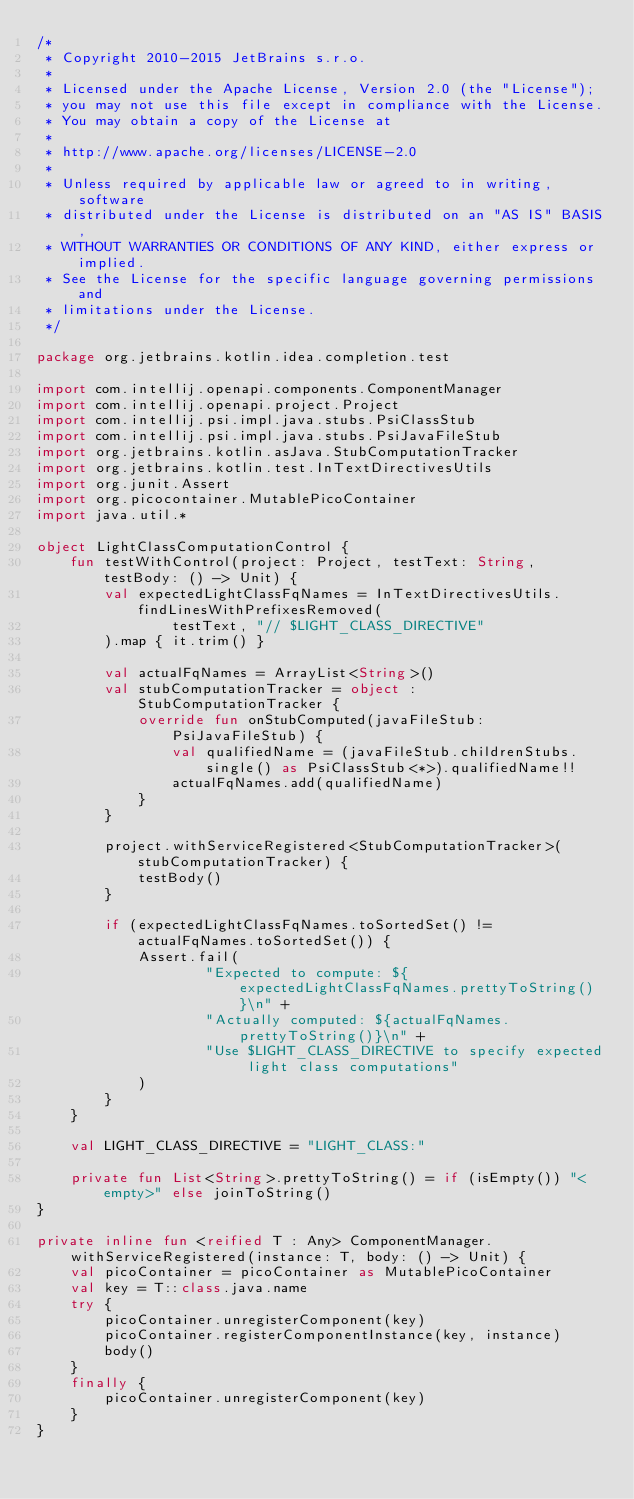<code> <loc_0><loc_0><loc_500><loc_500><_Kotlin_>/*
 * Copyright 2010-2015 JetBrains s.r.o.
 *
 * Licensed under the Apache License, Version 2.0 (the "License");
 * you may not use this file except in compliance with the License.
 * You may obtain a copy of the License at
 *
 * http://www.apache.org/licenses/LICENSE-2.0
 *
 * Unless required by applicable law or agreed to in writing, software
 * distributed under the License is distributed on an "AS IS" BASIS,
 * WITHOUT WARRANTIES OR CONDITIONS OF ANY KIND, either express or implied.
 * See the License for the specific language governing permissions and
 * limitations under the License.
 */

package org.jetbrains.kotlin.idea.completion.test

import com.intellij.openapi.components.ComponentManager
import com.intellij.openapi.project.Project
import com.intellij.psi.impl.java.stubs.PsiClassStub
import com.intellij.psi.impl.java.stubs.PsiJavaFileStub
import org.jetbrains.kotlin.asJava.StubComputationTracker
import org.jetbrains.kotlin.test.InTextDirectivesUtils
import org.junit.Assert
import org.picocontainer.MutablePicoContainer
import java.util.*

object LightClassComputationControl {
    fun testWithControl(project: Project, testText: String, testBody: () -> Unit) {
        val expectedLightClassFqNames = InTextDirectivesUtils.findLinesWithPrefixesRemoved(
                testText, "// $LIGHT_CLASS_DIRECTIVE"
        ).map { it.trim() }

        val actualFqNames = ArrayList<String>()
        val stubComputationTracker = object : StubComputationTracker {
            override fun onStubComputed(javaFileStub: PsiJavaFileStub) {
                val qualifiedName = (javaFileStub.childrenStubs.single() as PsiClassStub<*>).qualifiedName!!
                actualFqNames.add(qualifiedName)
            }
        }

        project.withServiceRegistered<StubComputationTracker>(stubComputationTracker) {
            testBody()
        }

        if (expectedLightClassFqNames.toSortedSet() != actualFqNames.toSortedSet()) {
            Assert.fail(
                    "Expected to compute: ${expectedLightClassFqNames.prettyToString()}\n" +
                    "Actually computed: ${actualFqNames.prettyToString()}\n" +
                    "Use $LIGHT_CLASS_DIRECTIVE to specify expected light class computations"
            )
        }
    }

    val LIGHT_CLASS_DIRECTIVE = "LIGHT_CLASS:"

    private fun List<String>.prettyToString() = if (isEmpty()) "<empty>" else joinToString()
}

private inline fun <reified T : Any> ComponentManager.withServiceRegistered(instance: T, body: () -> Unit) {
    val picoContainer = picoContainer as MutablePicoContainer
    val key = T::class.java.name
    try {
        picoContainer.unregisterComponent(key)
        picoContainer.registerComponentInstance(key, instance)
        body()
    }
    finally {
        picoContainer.unregisterComponent(key)
    }
}
</code> 